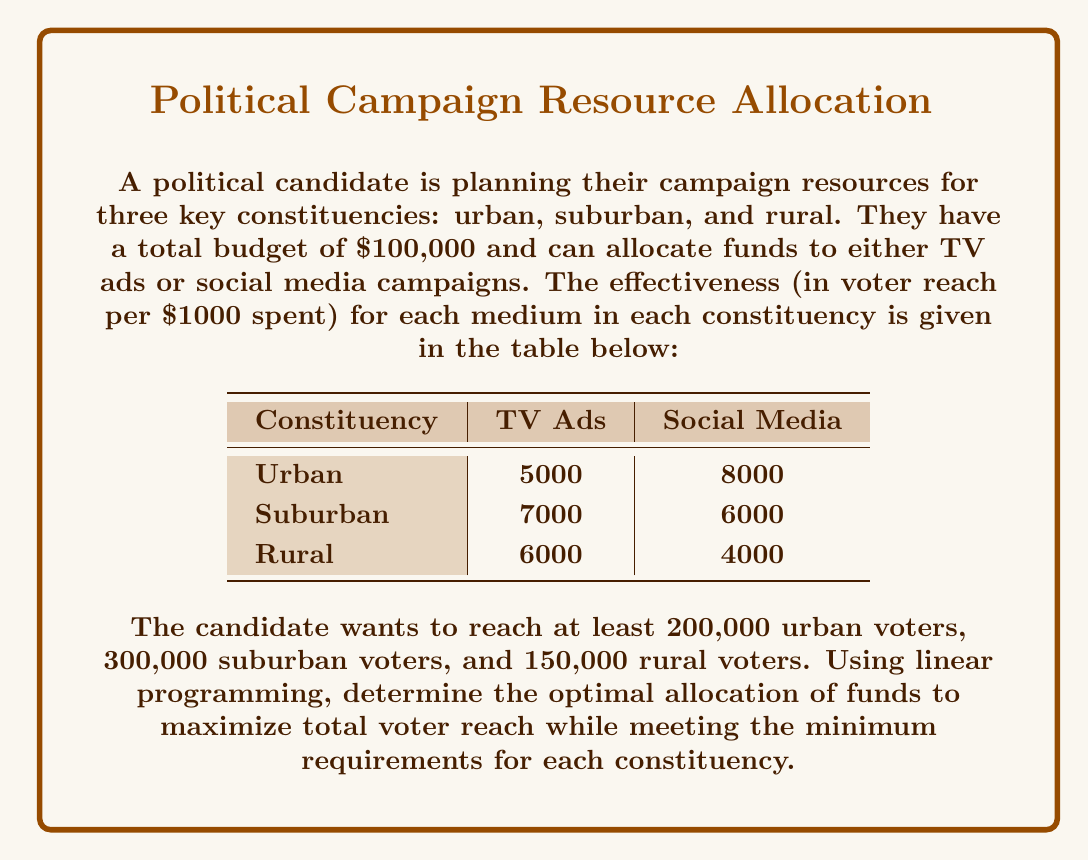Could you help me with this problem? Let's approach this step-by-step using linear programming:

1) Define variables:
   Let $x_1$ = amount spent on TV ads (in $1000s)
   Let $x_2$ = amount spent on social media (in $1000s)

2) Objective function:
   Maximize: $Z = 18000x_1 + 18000x_2$ (total voter reach across all constituencies)

3) Constraints:
   Budget: $x_1 + x_2 \leq 100$ (total budget is $100,000)
   Urban: $5000x_1 + 8000x_2 \geq 200000$
   Suburban: $7000x_1 + 6000x_2 \geq 300000$
   Rural: $6000x_1 + 4000x_2 \geq 150000$
   Non-negativity: $x_1, x_2 \geq 0$

4) Simplify constraints:
   $x_1 + x_2 \leq 100$
   $5x_1 + 8x_2 \geq 200$
   $7x_1 + 6x_2 \geq 300$
   $3x_1 + 2x_2 \geq 75$

5) Solve using the simplex method or a linear programming solver. The optimal solution is:
   $x_1 = 35.71$ (TV ads)
   $x_2 = 64.29$ (Social media)

6) Verify constraints:
   Budget: $35.71 + 64.29 = 100$ (satisfied)
   Urban: $5(35.71) + 8(64.29) = 692.86 > 200$ (satisfied)
   Suburban: $7(35.71) + 6(64.29) = 635.71 > 300$ (satisfied)
   Rural: $6(35.71) + 4(64.29) = 471.42 > 150$ (satisfied)

7) Calculate total voter reach:
   $Z = 18000(35.71) + 18000(64.29) = 1,800,000$ voters

Therefore, the optimal allocation is to spend $35,710 on TV ads and $64,290 on social media campaigns, reaching a total of 1,800,000 voters.
Answer: $35,710 on TV ads, $64,290 on social media 